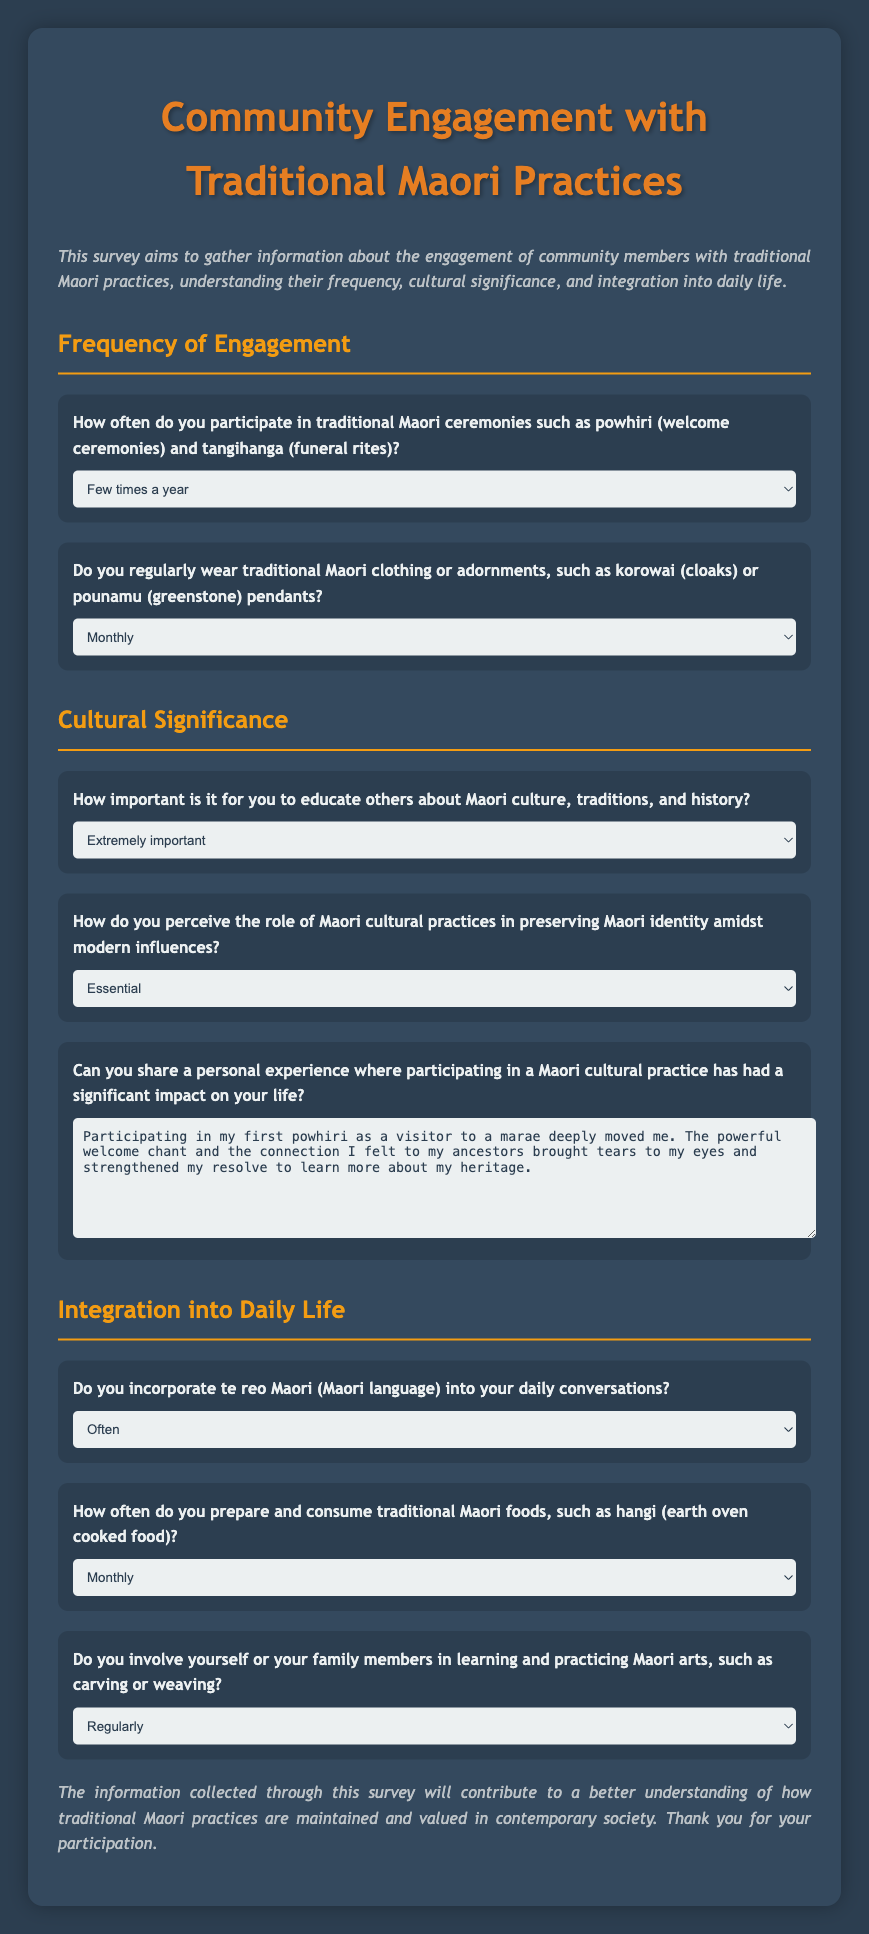What is the title of the survey? The title of the survey is found in the header section of the document, which states "Community Engagement with Traditional Maori Practices."
Answer: Community Engagement with Traditional Maori Practices How often do respondents participate in traditional Maori ceremonies? The survey provides options for how often individuals participate, with the selected option being "Few times a year."
Answer: Few times a year What is deemed essential for preserving Maori identity? The survey asks about the role of Maori cultural practices, with the selected response being "Essential."
Answer: Essential What frequency do individuals wear traditional Maori clothing? The options provided include various frequencies, with the selected response being "Monthly."
Answer: Monthly How important is educating others about Maori culture? The survey includes options for importance, with the selected response being "Extremely important."
Answer: Extremely important What is the selected frequency for preparing traditional Maori foods? The options for preparing and consuming foods are addressed, with the selected frequency being "Monthly."
Answer: Monthly How often do respondents incorporate te reo Maori into their conversations? The answers range in frequency, with the selected option being "Often."
Answer: Often In what area do participants engage in Maori arts? The survey asks about involvement in arts, with the selected response indicating "Regularly."
Answer: Regularly What personal experience is shared about Maori cultural practices? A provided response details a significant experience during a powhiri, which is mentioned explicitly in the text.
Answer: Participating in my first powhiri as a visitor to a marae deeply moved me 